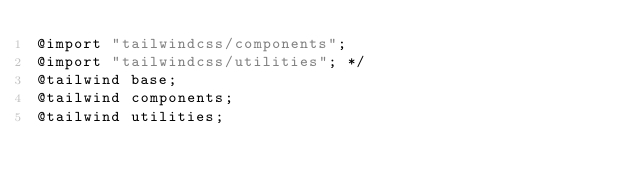Convert code to text. <code><loc_0><loc_0><loc_500><loc_500><_CSS_>@import "tailwindcss/components";
@import "tailwindcss/utilities"; */
@tailwind base;
@tailwind components;
@tailwind utilities;</code> 